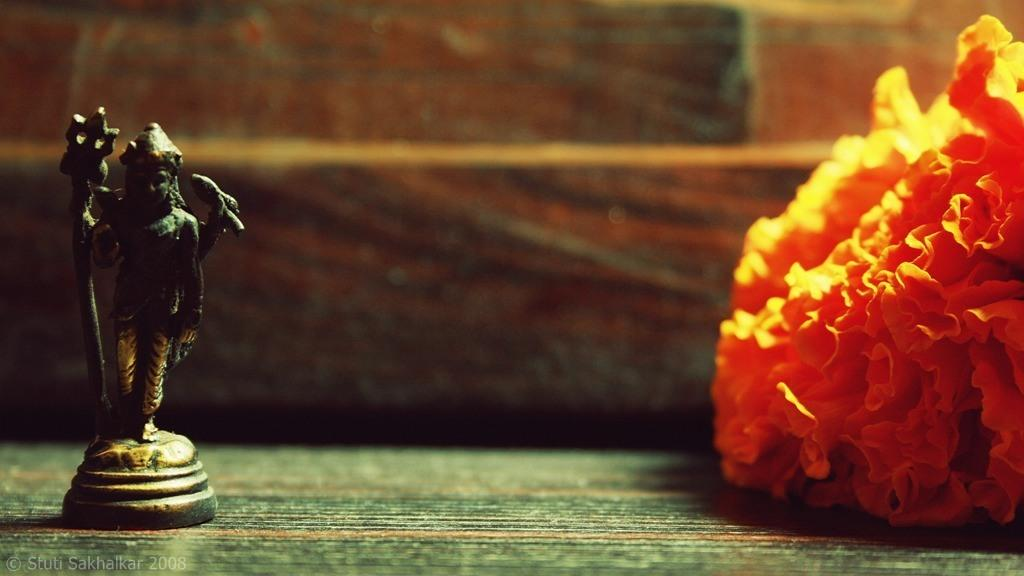What is located in the left corner of the image? There is an idol in the left corner of the image. What is present in the right corner of the image? There is an orange color object in the right corner of the image. Can you tell me how many owls are depicted in the image? There are no owls present in the image; it only features an idol and an orange color object. What type of stick is being used by the idol in the image? There is no stick present in the image; the idol is the only subject mentioned in the provided facts. 